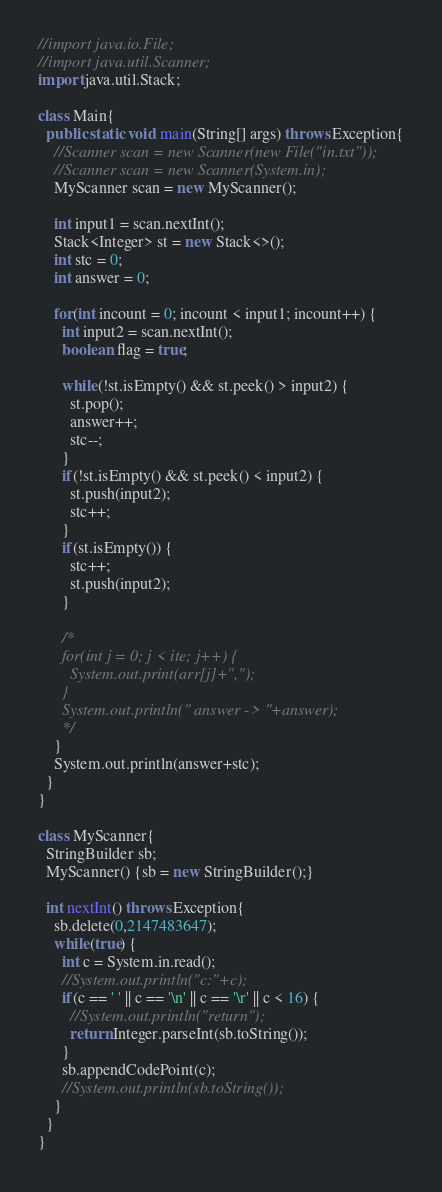<code> <loc_0><loc_0><loc_500><loc_500><_Java_>//import java.io.File;
//import java.util.Scanner;
import java.util.Stack;

class Main{
  public static void main(String[] args) throws Exception{
    //Scanner scan = new Scanner(new File("in.txt"));
    //Scanner scan = new Scanner(System.in);
    MyScanner scan = new MyScanner();

    int input1 = scan.nextInt();
    Stack<Integer> st = new Stack<>();
    int stc = 0;
    int answer = 0;

    for(int incount = 0; incount < input1; incount++) {
      int input2 = scan.nextInt();
      boolean flag = true;

      while(!st.isEmpty() && st.peek() > input2) {
        st.pop();
        answer++;
        stc--;
      }
      if(!st.isEmpty() && st.peek() < input2) {
        st.push(input2);
        stc++;
      }
      if(st.isEmpty()) {
        stc++;
        st.push(input2);
      }

      /*
      for(int j = 0; j < ite; j++) {
        System.out.print(arr[j]+",");
      }
      System.out.println(" answer -> "+answer);
      */
    }
    System.out.println(answer+stc);
  }
}

class MyScanner{
  StringBuilder sb;
  MyScanner() {sb = new StringBuilder();}

  int nextInt() throws Exception{
    sb.delete(0,2147483647);
    while(true) {
      int c = System.in.read();
      //System.out.println("c:"+c);
      if(c == ' ' || c == '\n' || c == '\r' || c < 16) {
        //System.out.println("return");
        return Integer.parseInt(sb.toString());
      }
      sb.appendCodePoint(c);
      //System.out.println(sb.toString());
    }
  }
}</code> 